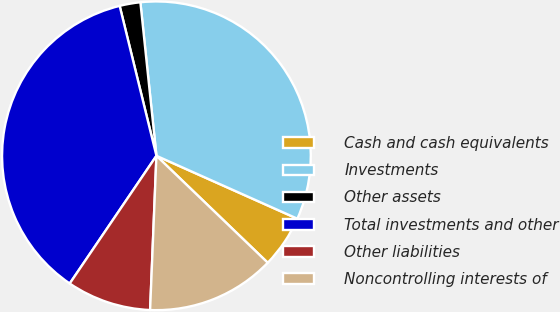Convert chart. <chart><loc_0><loc_0><loc_500><loc_500><pie_chart><fcel>Cash and cash equivalents<fcel>Investments<fcel>Other assets<fcel>Total investments and other<fcel>Other liabilities<fcel>Noncontrolling interests of<nl><fcel>5.5%<fcel>33.34%<fcel>2.17%<fcel>36.68%<fcel>8.84%<fcel>13.47%<nl></chart> 